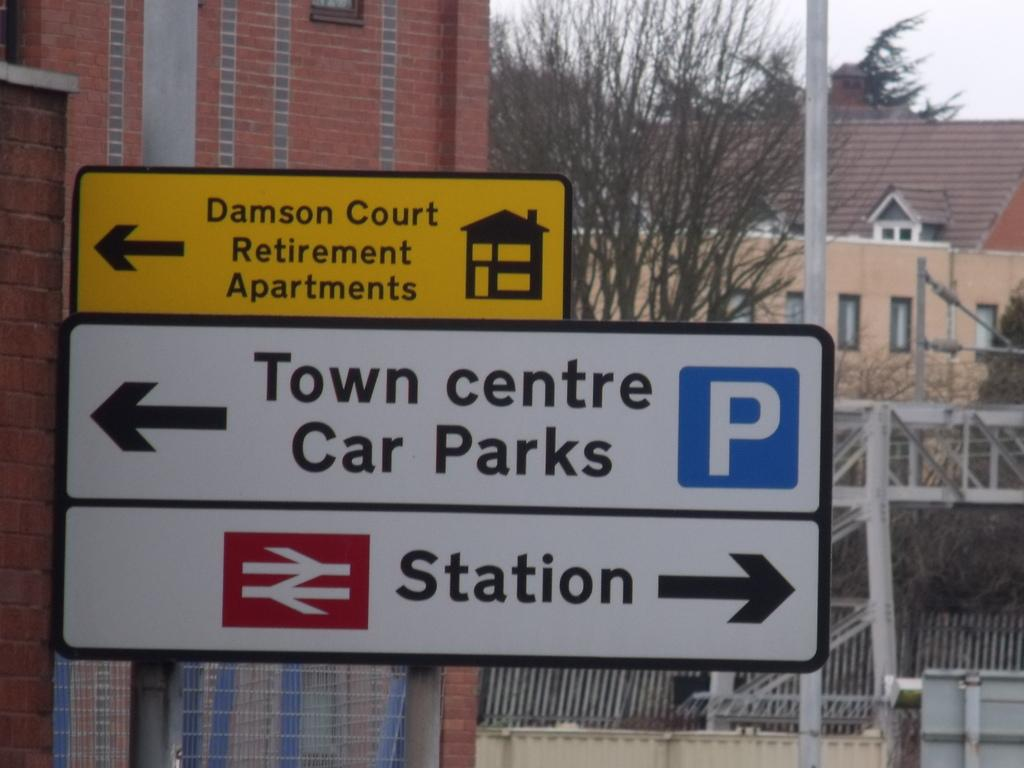<image>
Summarize the visual content of the image. A road sign showing the way to Town Centre Car Parks. 